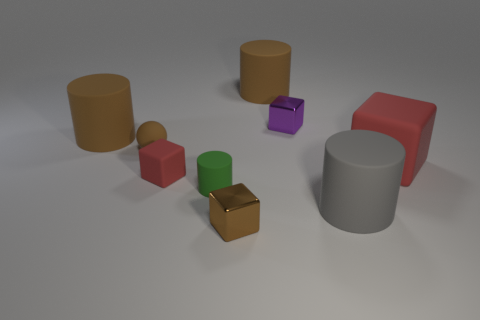Subtract all gray cylinders. How many cylinders are left? 3 Subtract all red blocks. How many blocks are left? 2 Add 1 small purple rubber objects. How many objects exist? 10 Subtract 1 cylinders. How many cylinders are left? 3 Subtract all purple cylinders. How many blue blocks are left? 0 Add 8 large brown matte objects. How many large brown matte objects exist? 10 Subtract 0 red balls. How many objects are left? 9 Subtract all cylinders. How many objects are left? 5 Subtract all gray balls. Subtract all gray cylinders. How many balls are left? 1 Subtract all green spheres. Subtract all tiny red rubber things. How many objects are left? 8 